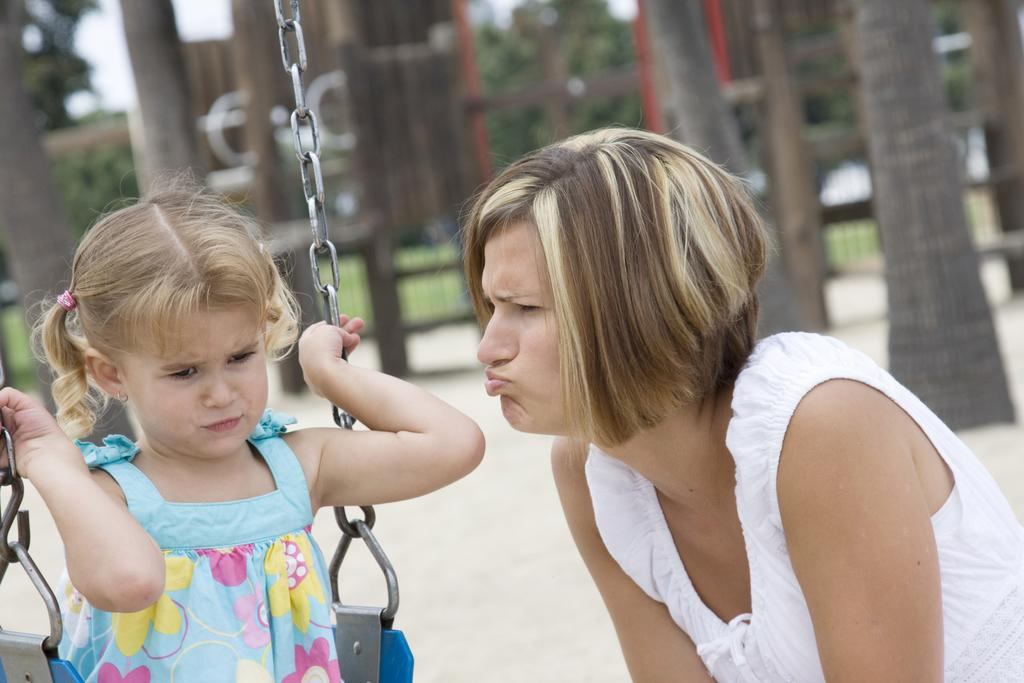What is the main activity of the person in the image? The person is standing on a path in the image. What is the kid doing in the image? The kid is sitting on a swing in the image. What type of vegetation can be seen behind the people in the image? There are trees behind the people in the image. What part of the trees is visible in the image? Tree trunks are visible in the image. What can be seen in the background of the image that is not clearly identifiable? There are some blurred objects in the background of the image. What type of net is being used to catch fish in the image? There is no net or fish present in the image; it features a person standing on a path and a kid sitting on a swing. What message is written on the note that the person is holding in the image? There is no note present in the image. 